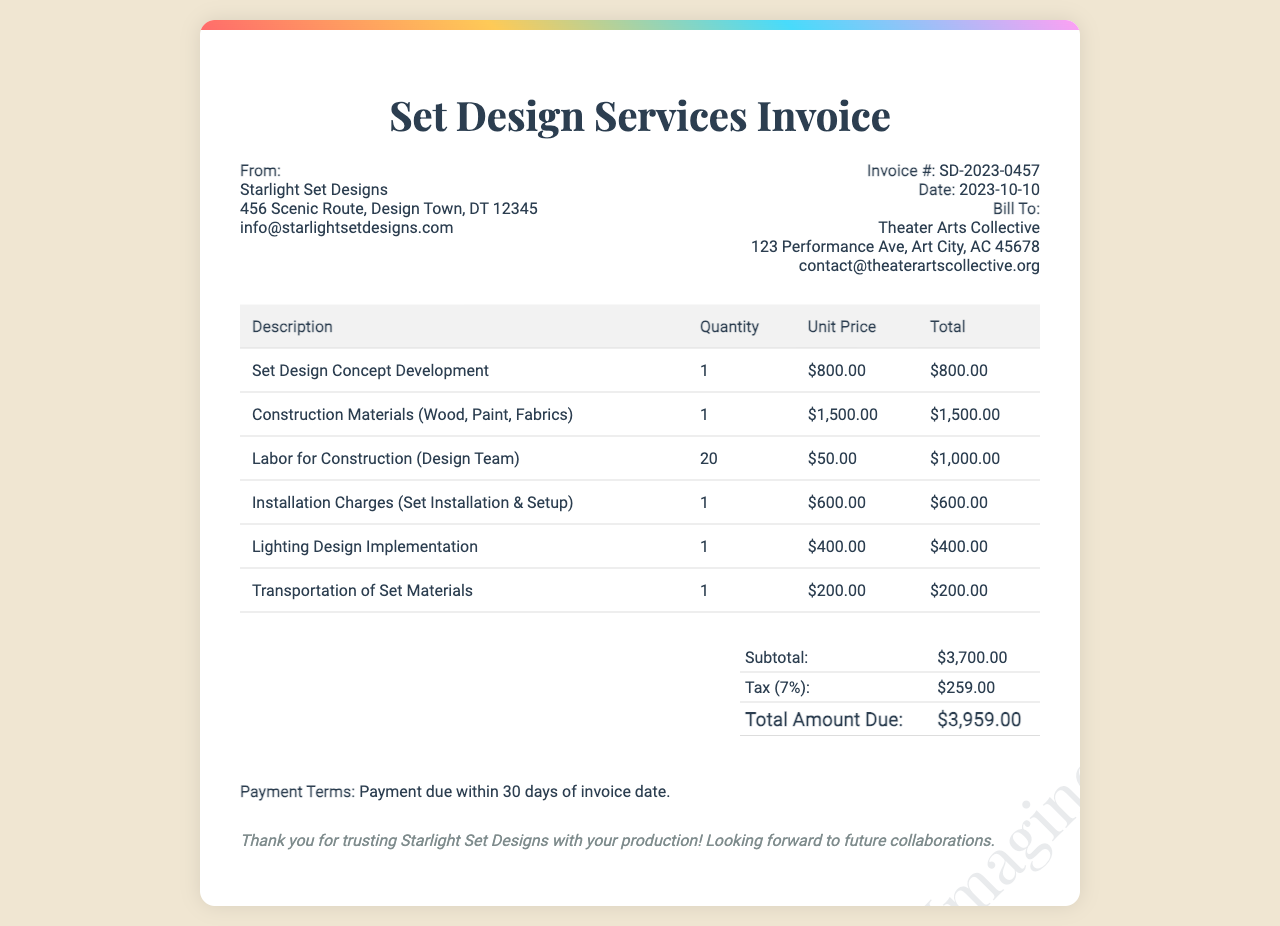What is the invoice number? The invoice number is clearly listed in the invoice details section.
Answer: SD-2023-0457 What is the date of the invoice? The date is provided next to the invoice number in the invoice details section.
Answer: 2023-10-10 Who is the billing party? The billing party is specified in the invoice details section under "Bill To."
Answer: Theater Arts Collective What is the subtotal amount? The subtotal is summarized at the bottom of the invoice, combining the charges before tax.
Answer: $3,700.00 What is the total amount due? The total amount is calculated at the end of the summary table and indicates what is owed.
Answer: $3,959.00 How many hours of labor are listed for construction? The labor for construction is represented as a quantity of labor hours in the invoice.
Answer: 20 What type of service has a charge of $800.00? The service descriptions provide specific charges, including for set design concept development.
Answer: Set Design Concept Development What percentage is the tax applied? The tax percentage is explicitly stated alongside the total calculations in the summary section.
Answer: 7% What is the payment terms specified in the invoice? The payment terms detail when the payment is due and are found towards the bottom of the invoice.
Answer: Payment due within 30 days of invoice date 